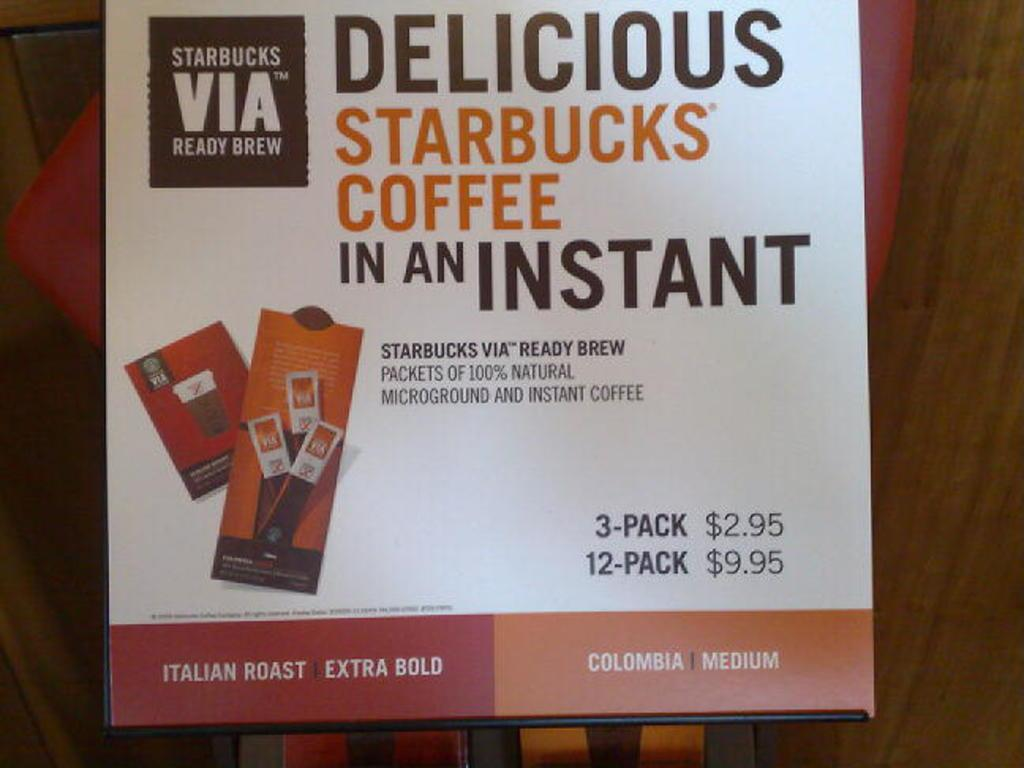Provide a one-sentence caption for the provided image. A poster advertising Delicious Starbucks Coffee in an Instant. 